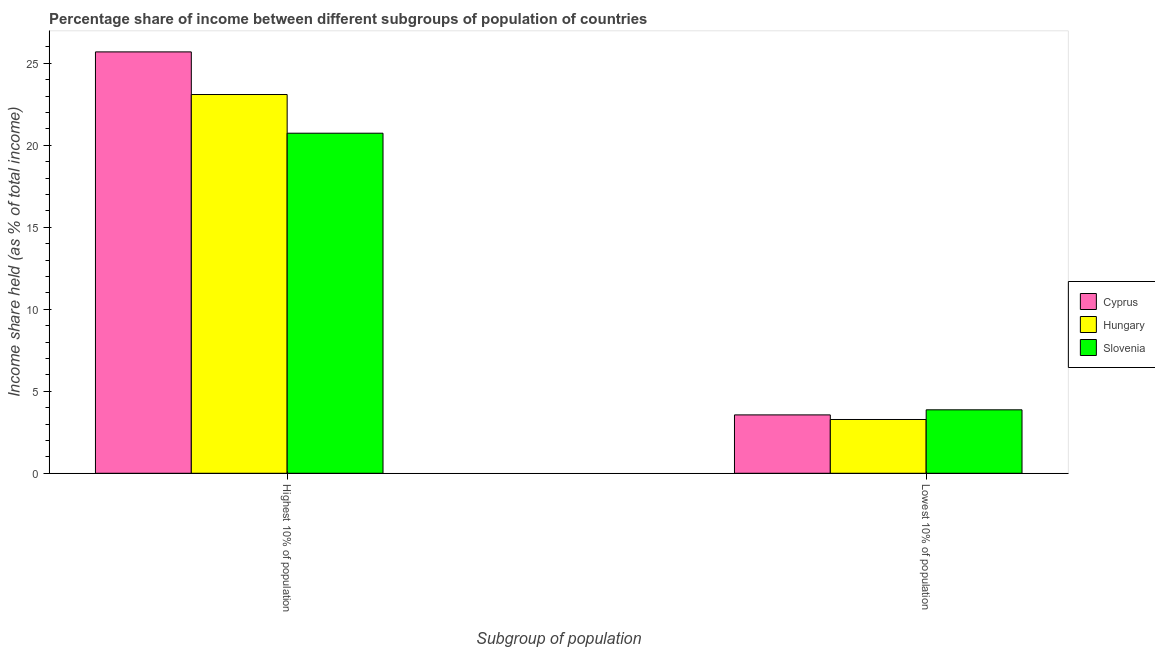What is the label of the 2nd group of bars from the left?
Your answer should be very brief. Lowest 10% of population. What is the income share held by highest 10% of the population in Hungary?
Give a very brief answer. 23.1. Across all countries, what is the maximum income share held by highest 10% of the population?
Keep it short and to the point. 25.7. Across all countries, what is the minimum income share held by lowest 10% of the population?
Provide a succinct answer. 3.28. In which country was the income share held by lowest 10% of the population maximum?
Offer a terse response. Slovenia. In which country was the income share held by lowest 10% of the population minimum?
Offer a very short reply. Hungary. What is the total income share held by highest 10% of the population in the graph?
Your response must be concise. 69.54. What is the difference between the income share held by highest 10% of the population in Hungary and that in Cyprus?
Offer a very short reply. -2.6. What is the difference between the income share held by highest 10% of the population in Hungary and the income share held by lowest 10% of the population in Cyprus?
Ensure brevity in your answer.  19.54. What is the average income share held by lowest 10% of the population per country?
Your answer should be very brief. 3.57. What is the difference between the income share held by lowest 10% of the population and income share held by highest 10% of the population in Hungary?
Your answer should be compact. -19.82. In how many countries, is the income share held by lowest 10% of the population greater than 24 %?
Offer a very short reply. 0. What is the ratio of the income share held by highest 10% of the population in Hungary to that in Slovenia?
Offer a very short reply. 1.11. Is the income share held by lowest 10% of the population in Slovenia less than that in Cyprus?
Ensure brevity in your answer.  No. What does the 2nd bar from the left in Lowest 10% of population represents?
Offer a terse response. Hungary. What does the 2nd bar from the right in Lowest 10% of population represents?
Make the answer very short. Hungary. How many countries are there in the graph?
Give a very brief answer. 3. What is the difference between two consecutive major ticks on the Y-axis?
Make the answer very short. 5. Where does the legend appear in the graph?
Provide a succinct answer. Center right. What is the title of the graph?
Your response must be concise. Percentage share of income between different subgroups of population of countries. What is the label or title of the X-axis?
Give a very brief answer. Subgroup of population. What is the label or title of the Y-axis?
Ensure brevity in your answer.  Income share held (as % of total income). What is the Income share held (as % of total income) in Cyprus in Highest 10% of population?
Your answer should be very brief. 25.7. What is the Income share held (as % of total income) in Hungary in Highest 10% of population?
Provide a short and direct response. 23.1. What is the Income share held (as % of total income) of Slovenia in Highest 10% of population?
Provide a succinct answer. 20.74. What is the Income share held (as % of total income) of Cyprus in Lowest 10% of population?
Ensure brevity in your answer.  3.56. What is the Income share held (as % of total income) of Hungary in Lowest 10% of population?
Your answer should be very brief. 3.28. What is the Income share held (as % of total income) of Slovenia in Lowest 10% of population?
Ensure brevity in your answer.  3.87. Across all Subgroup of population, what is the maximum Income share held (as % of total income) in Cyprus?
Offer a very short reply. 25.7. Across all Subgroup of population, what is the maximum Income share held (as % of total income) in Hungary?
Your answer should be very brief. 23.1. Across all Subgroup of population, what is the maximum Income share held (as % of total income) in Slovenia?
Your answer should be compact. 20.74. Across all Subgroup of population, what is the minimum Income share held (as % of total income) of Cyprus?
Offer a terse response. 3.56. Across all Subgroup of population, what is the minimum Income share held (as % of total income) in Hungary?
Give a very brief answer. 3.28. Across all Subgroup of population, what is the minimum Income share held (as % of total income) of Slovenia?
Make the answer very short. 3.87. What is the total Income share held (as % of total income) in Cyprus in the graph?
Your response must be concise. 29.26. What is the total Income share held (as % of total income) of Hungary in the graph?
Keep it short and to the point. 26.38. What is the total Income share held (as % of total income) of Slovenia in the graph?
Your answer should be very brief. 24.61. What is the difference between the Income share held (as % of total income) in Cyprus in Highest 10% of population and that in Lowest 10% of population?
Offer a terse response. 22.14. What is the difference between the Income share held (as % of total income) in Hungary in Highest 10% of population and that in Lowest 10% of population?
Your answer should be compact. 19.82. What is the difference between the Income share held (as % of total income) of Slovenia in Highest 10% of population and that in Lowest 10% of population?
Provide a succinct answer. 16.87. What is the difference between the Income share held (as % of total income) of Cyprus in Highest 10% of population and the Income share held (as % of total income) of Hungary in Lowest 10% of population?
Provide a short and direct response. 22.42. What is the difference between the Income share held (as % of total income) of Cyprus in Highest 10% of population and the Income share held (as % of total income) of Slovenia in Lowest 10% of population?
Ensure brevity in your answer.  21.83. What is the difference between the Income share held (as % of total income) in Hungary in Highest 10% of population and the Income share held (as % of total income) in Slovenia in Lowest 10% of population?
Your answer should be very brief. 19.23. What is the average Income share held (as % of total income) of Cyprus per Subgroup of population?
Offer a terse response. 14.63. What is the average Income share held (as % of total income) in Hungary per Subgroup of population?
Ensure brevity in your answer.  13.19. What is the average Income share held (as % of total income) of Slovenia per Subgroup of population?
Give a very brief answer. 12.3. What is the difference between the Income share held (as % of total income) in Cyprus and Income share held (as % of total income) in Hungary in Highest 10% of population?
Give a very brief answer. 2.6. What is the difference between the Income share held (as % of total income) of Cyprus and Income share held (as % of total income) of Slovenia in Highest 10% of population?
Provide a succinct answer. 4.96. What is the difference between the Income share held (as % of total income) of Hungary and Income share held (as % of total income) of Slovenia in Highest 10% of population?
Your answer should be compact. 2.36. What is the difference between the Income share held (as % of total income) of Cyprus and Income share held (as % of total income) of Hungary in Lowest 10% of population?
Offer a very short reply. 0.28. What is the difference between the Income share held (as % of total income) of Cyprus and Income share held (as % of total income) of Slovenia in Lowest 10% of population?
Offer a terse response. -0.31. What is the difference between the Income share held (as % of total income) of Hungary and Income share held (as % of total income) of Slovenia in Lowest 10% of population?
Your answer should be compact. -0.59. What is the ratio of the Income share held (as % of total income) of Cyprus in Highest 10% of population to that in Lowest 10% of population?
Keep it short and to the point. 7.22. What is the ratio of the Income share held (as % of total income) of Hungary in Highest 10% of population to that in Lowest 10% of population?
Offer a terse response. 7.04. What is the ratio of the Income share held (as % of total income) of Slovenia in Highest 10% of population to that in Lowest 10% of population?
Provide a succinct answer. 5.36. What is the difference between the highest and the second highest Income share held (as % of total income) in Cyprus?
Offer a very short reply. 22.14. What is the difference between the highest and the second highest Income share held (as % of total income) in Hungary?
Offer a very short reply. 19.82. What is the difference between the highest and the second highest Income share held (as % of total income) in Slovenia?
Offer a very short reply. 16.87. What is the difference between the highest and the lowest Income share held (as % of total income) in Cyprus?
Provide a succinct answer. 22.14. What is the difference between the highest and the lowest Income share held (as % of total income) of Hungary?
Your answer should be very brief. 19.82. What is the difference between the highest and the lowest Income share held (as % of total income) of Slovenia?
Make the answer very short. 16.87. 